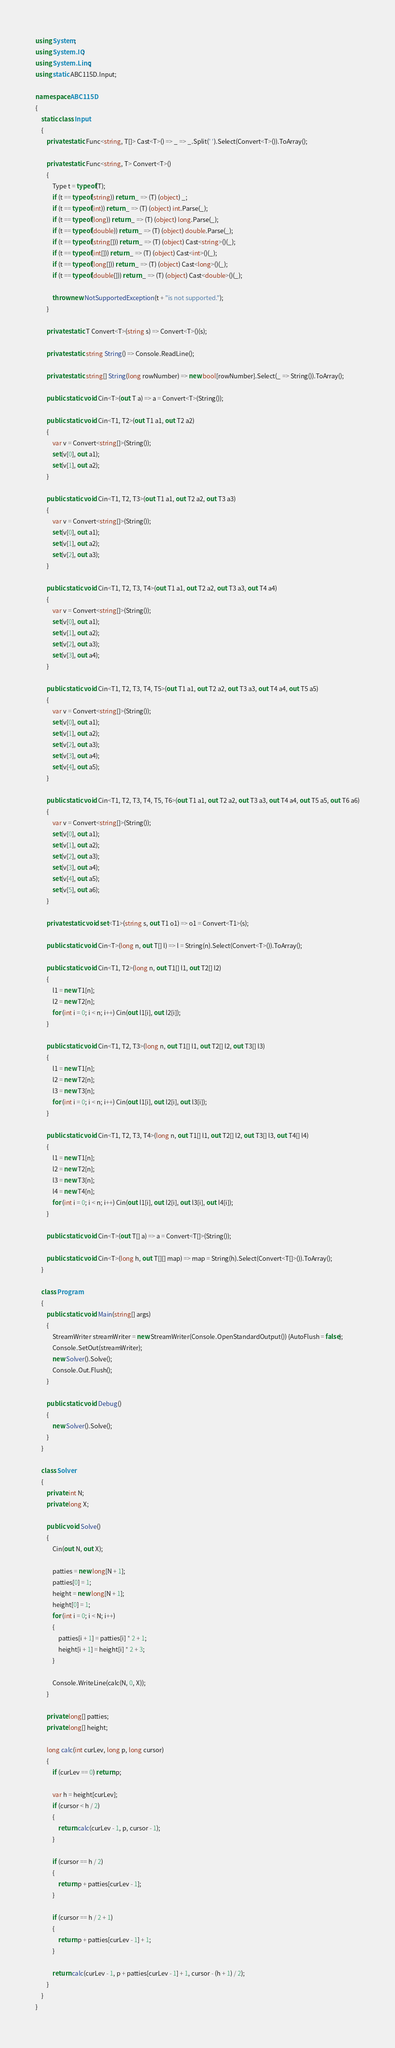<code> <loc_0><loc_0><loc_500><loc_500><_C#_>using System;
using System.IO;
using System.Linq;
using static ABC115D.Input;

namespace ABC115D
{
    static class Input
    {
        private static Func<string, T[]> Cast<T>() => _ => _.Split(' ').Select(Convert<T>()).ToArray();

        private static Func<string, T> Convert<T>()
        {
            Type t = typeof(T);
            if (t == typeof(string)) return _ => (T) (object) _;
            if (t == typeof(int)) return _ => (T) (object) int.Parse(_);
            if (t == typeof(long)) return _ => (T) (object) long.Parse(_);
            if (t == typeof(double)) return _ => (T) (object) double.Parse(_);
            if (t == typeof(string[])) return _ => (T) (object) Cast<string>()(_);
            if (t == typeof(int[])) return _ => (T) (object) Cast<int>()(_);
            if (t == typeof(long[])) return _ => (T) (object) Cast<long>()(_);
            if (t == typeof(double[])) return _ => (T) (object) Cast<double>()(_);

            throw new NotSupportedException(t + "is not supported.");
        }

        private static T Convert<T>(string s) => Convert<T>()(s);

        private static string String() => Console.ReadLine();

        private static string[] String(long rowNumber) => new bool[rowNumber].Select(_ => String()).ToArray();

        public static void Cin<T>(out T a) => a = Convert<T>(String());

        public static void Cin<T1, T2>(out T1 a1, out T2 a2)
        {
            var v = Convert<string[]>(String());
            set(v[0], out a1);
            set(v[1], out a2);
        }

        public static void Cin<T1, T2, T3>(out T1 a1, out T2 a2, out T3 a3)
        {
            var v = Convert<string[]>(String());
            set(v[0], out a1);
            set(v[1], out a2);
            set(v[2], out a3);
        }

        public static void Cin<T1, T2, T3, T4>(out T1 a1, out T2 a2, out T3 a3, out T4 a4)
        {
            var v = Convert<string[]>(String());
            set(v[0], out a1);
            set(v[1], out a2);
            set(v[2], out a3);
            set(v[3], out a4);
        }

        public static void Cin<T1, T2, T3, T4, T5>(out T1 a1, out T2 a2, out T3 a3, out T4 a4, out T5 a5)
        {
            var v = Convert<string[]>(String());
            set(v[0], out a1);
            set(v[1], out a2);
            set(v[2], out a3);
            set(v[3], out a4);
            set(v[4], out a5);
        }

        public static void Cin<T1, T2, T3, T4, T5, T6>(out T1 a1, out T2 a2, out T3 a3, out T4 a4, out T5 a5, out T6 a6)
        {
            var v = Convert<string[]>(String());
            set(v[0], out a1);
            set(v[1], out a2);
            set(v[2], out a3);
            set(v[3], out a4);
            set(v[4], out a5);
            set(v[5], out a6);
        }

        private static void set<T1>(string s, out T1 o1) => o1 = Convert<T1>(s);

        public static void Cin<T>(long n, out T[] l) => l = String(n).Select(Convert<T>()).ToArray();

        public static void Cin<T1, T2>(long n, out T1[] l1, out T2[] l2)
        {
            l1 = new T1[n];
            l2 = new T2[n];
            for (int i = 0; i < n; i++) Cin(out l1[i], out l2[i]);
        }

        public static void Cin<T1, T2, T3>(long n, out T1[] l1, out T2[] l2, out T3[] l3)
        {
            l1 = new T1[n];
            l2 = new T2[n];
            l3 = new T3[n];
            for (int i = 0; i < n; i++) Cin(out l1[i], out l2[i], out l3[i]);
        }

        public static void Cin<T1, T2, T3, T4>(long n, out T1[] l1, out T2[] l2, out T3[] l3, out T4[] l4)
        {
            l1 = new T1[n];
            l2 = new T2[n];
            l3 = new T3[n];
            l4 = new T4[n];
            for (int i = 0; i < n; i++) Cin(out l1[i], out l2[i], out l3[i], out l4[i]);
        }

        public static void Cin<T>(out T[] a) => a = Convert<T[]>(String());

        public static void Cin<T>(long h, out T[][] map) => map = String(h).Select(Convert<T[]>()).ToArray();
    }

    class Program
    {
        public static void Main(string[] args)
        {
            StreamWriter streamWriter = new StreamWriter(Console.OpenStandardOutput()) {AutoFlush = false};
            Console.SetOut(streamWriter);
            new Solver().Solve();
            Console.Out.Flush();
        }

        public static void Debug()
        {
            new Solver().Solve();
        }
    }

    class Solver
    {
        private int N;
        private long X;

        public void Solve()
        {
            Cin(out N, out X);

            patties = new long[N + 1];
            patties[0] = 1;
            height = new long[N + 1];
            height[0] = 1;
            for (int i = 0; i < N; i++)
            {
                patties[i + 1] = patties[i] * 2 + 1;
                height[i + 1] = height[i] * 2 + 3;
            }

            Console.WriteLine(calc(N, 0, X));
        }

        private long[] patties;
        private long[] height;

        long calc(int curLev, long p, long cursor)
        {
            if (curLev == 0) return p;

            var h = height[curLev];
            if (cursor < h / 2)
            {
                return calc(curLev - 1, p, cursor - 1);
            }

            if (cursor == h / 2)
            {
                return p + patties[curLev - 1];
            }

            if (cursor == h / 2 + 1)
            {
                return p + patties[curLev - 1] + 1;
            }

            return calc(curLev - 1, p + patties[curLev - 1] + 1, cursor - (h + 1) / 2);
        }
    }
}</code> 